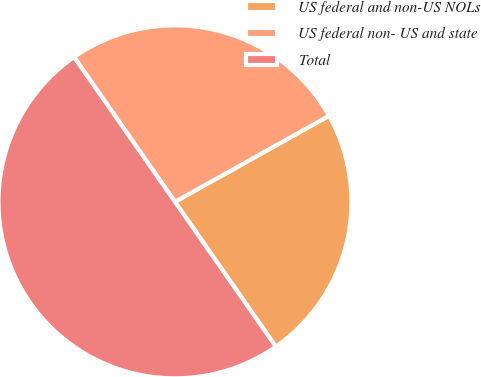Convert chart to OTSL. <chart><loc_0><loc_0><loc_500><loc_500><pie_chart><fcel>US federal and non-US NOLs<fcel>US federal non- US and state<fcel>Total<nl><fcel>23.42%<fcel>26.58%<fcel>50.0%<nl></chart> 